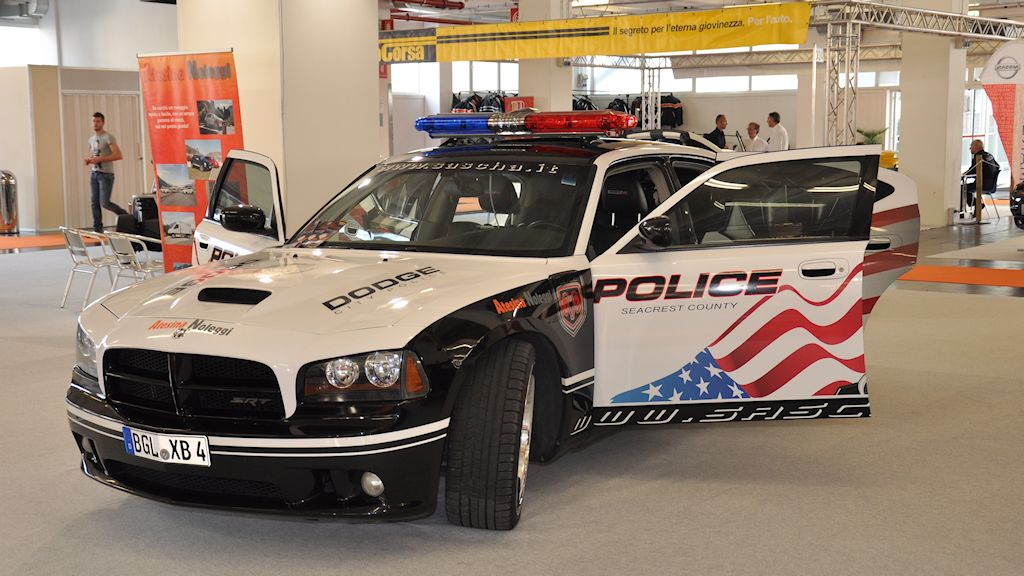What features on this police vehicle make it stand out in a crowded environment? This police vehicle stands out due to its striking design elements, including the large American flag graphic on the side that instantly catches the eye. Additionally, the bold 'POLICE' lettering in uppercase, along with the detailed Seacrest County emblem, ensures that its purpose is unmistakable. The use of bright, high-contrast colors, integrated lighting, and unique branding like 'DODGE' and 'SRT' logos also enhance its visibility, making it noticeable even in congested areas. 